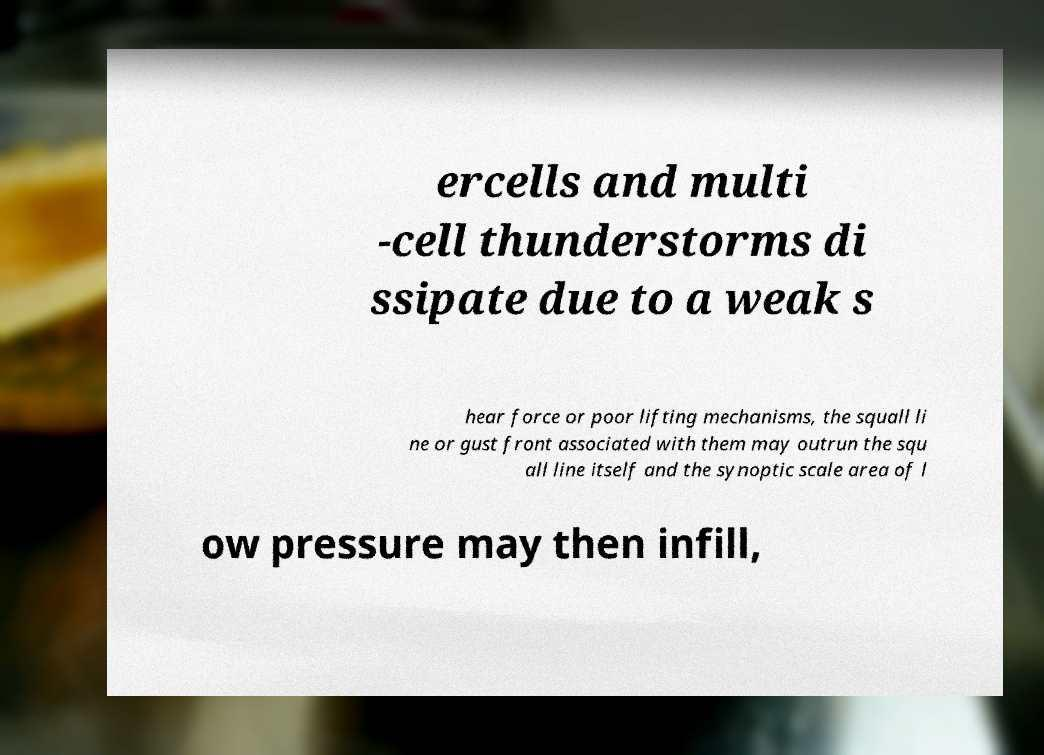Can you read and provide the text displayed in the image?This photo seems to have some interesting text. Can you extract and type it out for me? ercells and multi -cell thunderstorms di ssipate due to a weak s hear force or poor lifting mechanisms, the squall li ne or gust front associated with them may outrun the squ all line itself and the synoptic scale area of l ow pressure may then infill, 